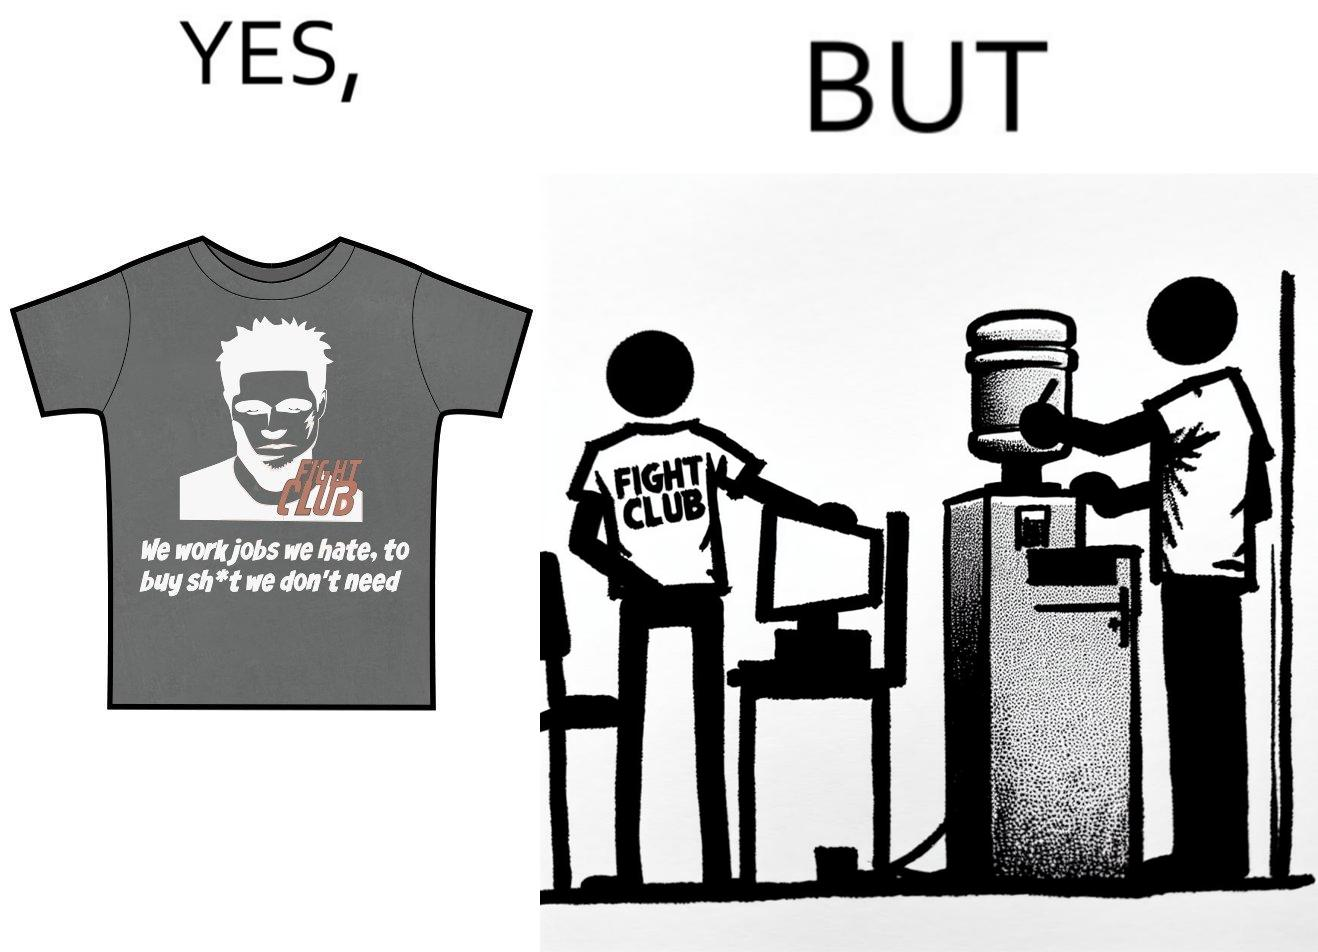What is shown in the left half versus the right half of this image? In the left part of the image: a t-shirt with "Fight Club" written on it (referring to the movie), along with a dialogue from the movie that says "We work jobs we hate, to buy sh*t we don't need". In the right part of the image: a person wearing a t-shirt that says "Fight Club", working on a computer system, with a water dispenser by the side. 